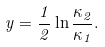<formula> <loc_0><loc_0><loc_500><loc_500>y = \frac { 1 } { 2 } \ln \frac { \kappa _ { 2 } } { \kappa _ { 1 } } .</formula> 